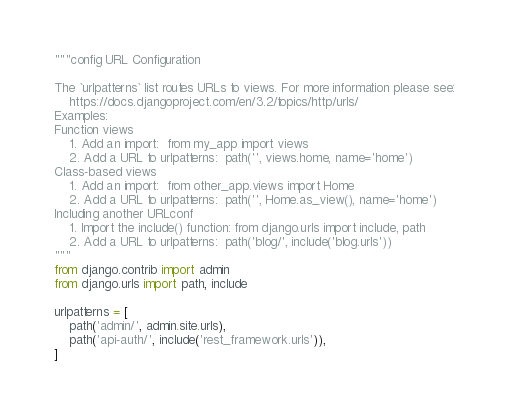<code> <loc_0><loc_0><loc_500><loc_500><_Python_>"""config URL Configuration

The `urlpatterns` list routes URLs to views. For more information please see:
    https://docs.djangoproject.com/en/3.2/topics/http/urls/
Examples:
Function views
    1. Add an import:  from my_app import views
    2. Add a URL to urlpatterns:  path('', views.home, name='home')
Class-based views
    1. Add an import:  from other_app.views import Home
    2. Add a URL to urlpatterns:  path('', Home.as_view(), name='home')
Including another URLconf
    1. Import the include() function: from django.urls import include, path
    2. Add a URL to urlpatterns:  path('blog/', include('blog.urls'))
"""
from django.contrib import admin
from django.urls import path, include

urlpatterns = [
    path('admin/', admin.site.urls),
    path('api-auth/', include('rest_framework.urls')),
]
</code> 